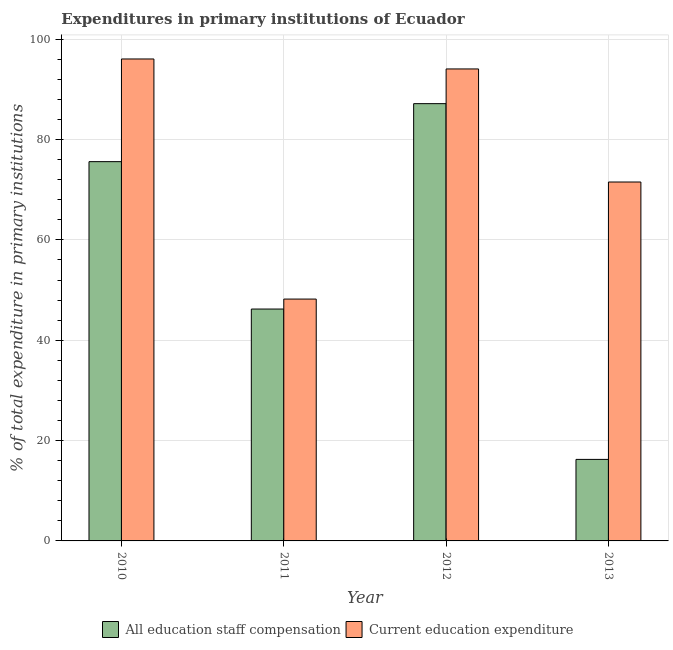How many different coloured bars are there?
Provide a short and direct response. 2. How many groups of bars are there?
Provide a succinct answer. 4. Are the number of bars per tick equal to the number of legend labels?
Your answer should be very brief. Yes. How many bars are there on the 3rd tick from the left?
Provide a succinct answer. 2. How many bars are there on the 4th tick from the right?
Ensure brevity in your answer.  2. What is the label of the 1st group of bars from the left?
Make the answer very short. 2010. What is the expenditure in staff compensation in 2011?
Give a very brief answer. 46.22. Across all years, what is the maximum expenditure in staff compensation?
Ensure brevity in your answer.  87.17. Across all years, what is the minimum expenditure in staff compensation?
Keep it short and to the point. 16.25. What is the total expenditure in staff compensation in the graph?
Make the answer very short. 225.25. What is the difference between the expenditure in education in 2012 and that in 2013?
Make the answer very short. 22.54. What is the difference between the expenditure in education in 2012 and the expenditure in staff compensation in 2010?
Your answer should be very brief. -1.99. What is the average expenditure in staff compensation per year?
Make the answer very short. 56.31. In how many years, is the expenditure in education greater than 48 %?
Offer a terse response. 4. What is the ratio of the expenditure in education in 2012 to that in 2013?
Your response must be concise. 1.32. What is the difference between the highest and the second highest expenditure in staff compensation?
Give a very brief answer. 11.56. What is the difference between the highest and the lowest expenditure in staff compensation?
Provide a short and direct response. 70.91. Is the sum of the expenditure in education in 2011 and 2013 greater than the maximum expenditure in staff compensation across all years?
Provide a succinct answer. Yes. What does the 1st bar from the left in 2011 represents?
Provide a succinct answer. All education staff compensation. What does the 2nd bar from the right in 2013 represents?
Provide a short and direct response. All education staff compensation. Are all the bars in the graph horizontal?
Ensure brevity in your answer.  No. How many years are there in the graph?
Keep it short and to the point. 4. Where does the legend appear in the graph?
Give a very brief answer. Bottom center. How many legend labels are there?
Your answer should be compact. 2. What is the title of the graph?
Provide a succinct answer. Expenditures in primary institutions of Ecuador. What is the label or title of the X-axis?
Ensure brevity in your answer.  Year. What is the label or title of the Y-axis?
Your response must be concise. % of total expenditure in primary institutions. What is the % of total expenditure in primary institutions in All education staff compensation in 2010?
Your response must be concise. 75.6. What is the % of total expenditure in primary institutions of Current education expenditure in 2010?
Offer a terse response. 96.07. What is the % of total expenditure in primary institutions of All education staff compensation in 2011?
Give a very brief answer. 46.22. What is the % of total expenditure in primary institutions of Current education expenditure in 2011?
Provide a short and direct response. 48.21. What is the % of total expenditure in primary institutions in All education staff compensation in 2012?
Your answer should be very brief. 87.17. What is the % of total expenditure in primary institutions of Current education expenditure in 2012?
Ensure brevity in your answer.  94.08. What is the % of total expenditure in primary institutions of All education staff compensation in 2013?
Give a very brief answer. 16.25. What is the % of total expenditure in primary institutions in Current education expenditure in 2013?
Your answer should be compact. 71.55. Across all years, what is the maximum % of total expenditure in primary institutions of All education staff compensation?
Keep it short and to the point. 87.17. Across all years, what is the maximum % of total expenditure in primary institutions of Current education expenditure?
Your response must be concise. 96.07. Across all years, what is the minimum % of total expenditure in primary institutions in All education staff compensation?
Provide a succinct answer. 16.25. Across all years, what is the minimum % of total expenditure in primary institutions in Current education expenditure?
Offer a very short reply. 48.21. What is the total % of total expenditure in primary institutions in All education staff compensation in the graph?
Your answer should be very brief. 225.25. What is the total % of total expenditure in primary institutions of Current education expenditure in the graph?
Provide a succinct answer. 309.91. What is the difference between the % of total expenditure in primary institutions of All education staff compensation in 2010 and that in 2011?
Provide a short and direct response. 29.38. What is the difference between the % of total expenditure in primary institutions in Current education expenditure in 2010 and that in 2011?
Offer a very short reply. 47.86. What is the difference between the % of total expenditure in primary institutions of All education staff compensation in 2010 and that in 2012?
Provide a succinct answer. -11.56. What is the difference between the % of total expenditure in primary institutions of Current education expenditure in 2010 and that in 2012?
Your answer should be very brief. 1.99. What is the difference between the % of total expenditure in primary institutions of All education staff compensation in 2010 and that in 2013?
Make the answer very short. 59.35. What is the difference between the % of total expenditure in primary institutions in Current education expenditure in 2010 and that in 2013?
Make the answer very short. 24.52. What is the difference between the % of total expenditure in primary institutions in All education staff compensation in 2011 and that in 2012?
Your answer should be very brief. -40.94. What is the difference between the % of total expenditure in primary institutions of Current education expenditure in 2011 and that in 2012?
Make the answer very short. -45.87. What is the difference between the % of total expenditure in primary institutions in All education staff compensation in 2011 and that in 2013?
Provide a succinct answer. 29.97. What is the difference between the % of total expenditure in primary institutions in Current education expenditure in 2011 and that in 2013?
Your response must be concise. -23.34. What is the difference between the % of total expenditure in primary institutions in All education staff compensation in 2012 and that in 2013?
Ensure brevity in your answer.  70.91. What is the difference between the % of total expenditure in primary institutions in Current education expenditure in 2012 and that in 2013?
Your answer should be very brief. 22.54. What is the difference between the % of total expenditure in primary institutions of All education staff compensation in 2010 and the % of total expenditure in primary institutions of Current education expenditure in 2011?
Your answer should be very brief. 27.39. What is the difference between the % of total expenditure in primary institutions in All education staff compensation in 2010 and the % of total expenditure in primary institutions in Current education expenditure in 2012?
Give a very brief answer. -18.48. What is the difference between the % of total expenditure in primary institutions of All education staff compensation in 2010 and the % of total expenditure in primary institutions of Current education expenditure in 2013?
Your answer should be very brief. 4.06. What is the difference between the % of total expenditure in primary institutions in All education staff compensation in 2011 and the % of total expenditure in primary institutions in Current education expenditure in 2012?
Offer a terse response. -47.86. What is the difference between the % of total expenditure in primary institutions in All education staff compensation in 2011 and the % of total expenditure in primary institutions in Current education expenditure in 2013?
Your answer should be very brief. -25.32. What is the difference between the % of total expenditure in primary institutions in All education staff compensation in 2012 and the % of total expenditure in primary institutions in Current education expenditure in 2013?
Offer a terse response. 15.62. What is the average % of total expenditure in primary institutions in All education staff compensation per year?
Give a very brief answer. 56.31. What is the average % of total expenditure in primary institutions in Current education expenditure per year?
Keep it short and to the point. 77.48. In the year 2010, what is the difference between the % of total expenditure in primary institutions in All education staff compensation and % of total expenditure in primary institutions in Current education expenditure?
Give a very brief answer. -20.47. In the year 2011, what is the difference between the % of total expenditure in primary institutions in All education staff compensation and % of total expenditure in primary institutions in Current education expenditure?
Offer a very short reply. -1.99. In the year 2012, what is the difference between the % of total expenditure in primary institutions of All education staff compensation and % of total expenditure in primary institutions of Current education expenditure?
Provide a short and direct response. -6.92. In the year 2013, what is the difference between the % of total expenditure in primary institutions in All education staff compensation and % of total expenditure in primary institutions in Current education expenditure?
Provide a short and direct response. -55.29. What is the ratio of the % of total expenditure in primary institutions in All education staff compensation in 2010 to that in 2011?
Offer a terse response. 1.64. What is the ratio of the % of total expenditure in primary institutions of Current education expenditure in 2010 to that in 2011?
Give a very brief answer. 1.99. What is the ratio of the % of total expenditure in primary institutions in All education staff compensation in 2010 to that in 2012?
Give a very brief answer. 0.87. What is the ratio of the % of total expenditure in primary institutions of Current education expenditure in 2010 to that in 2012?
Your response must be concise. 1.02. What is the ratio of the % of total expenditure in primary institutions in All education staff compensation in 2010 to that in 2013?
Offer a terse response. 4.65. What is the ratio of the % of total expenditure in primary institutions of Current education expenditure in 2010 to that in 2013?
Provide a succinct answer. 1.34. What is the ratio of the % of total expenditure in primary institutions of All education staff compensation in 2011 to that in 2012?
Your answer should be very brief. 0.53. What is the ratio of the % of total expenditure in primary institutions of Current education expenditure in 2011 to that in 2012?
Provide a short and direct response. 0.51. What is the ratio of the % of total expenditure in primary institutions in All education staff compensation in 2011 to that in 2013?
Provide a succinct answer. 2.84. What is the ratio of the % of total expenditure in primary institutions of Current education expenditure in 2011 to that in 2013?
Your response must be concise. 0.67. What is the ratio of the % of total expenditure in primary institutions in All education staff compensation in 2012 to that in 2013?
Offer a very short reply. 5.36. What is the ratio of the % of total expenditure in primary institutions in Current education expenditure in 2012 to that in 2013?
Give a very brief answer. 1.31. What is the difference between the highest and the second highest % of total expenditure in primary institutions in All education staff compensation?
Provide a short and direct response. 11.56. What is the difference between the highest and the second highest % of total expenditure in primary institutions of Current education expenditure?
Ensure brevity in your answer.  1.99. What is the difference between the highest and the lowest % of total expenditure in primary institutions in All education staff compensation?
Provide a succinct answer. 70.91. What is the difference between the highest and the lowest % of total expenditure in primary institutions in Current education expenditure?
Your answer should be compact. 47.86. 